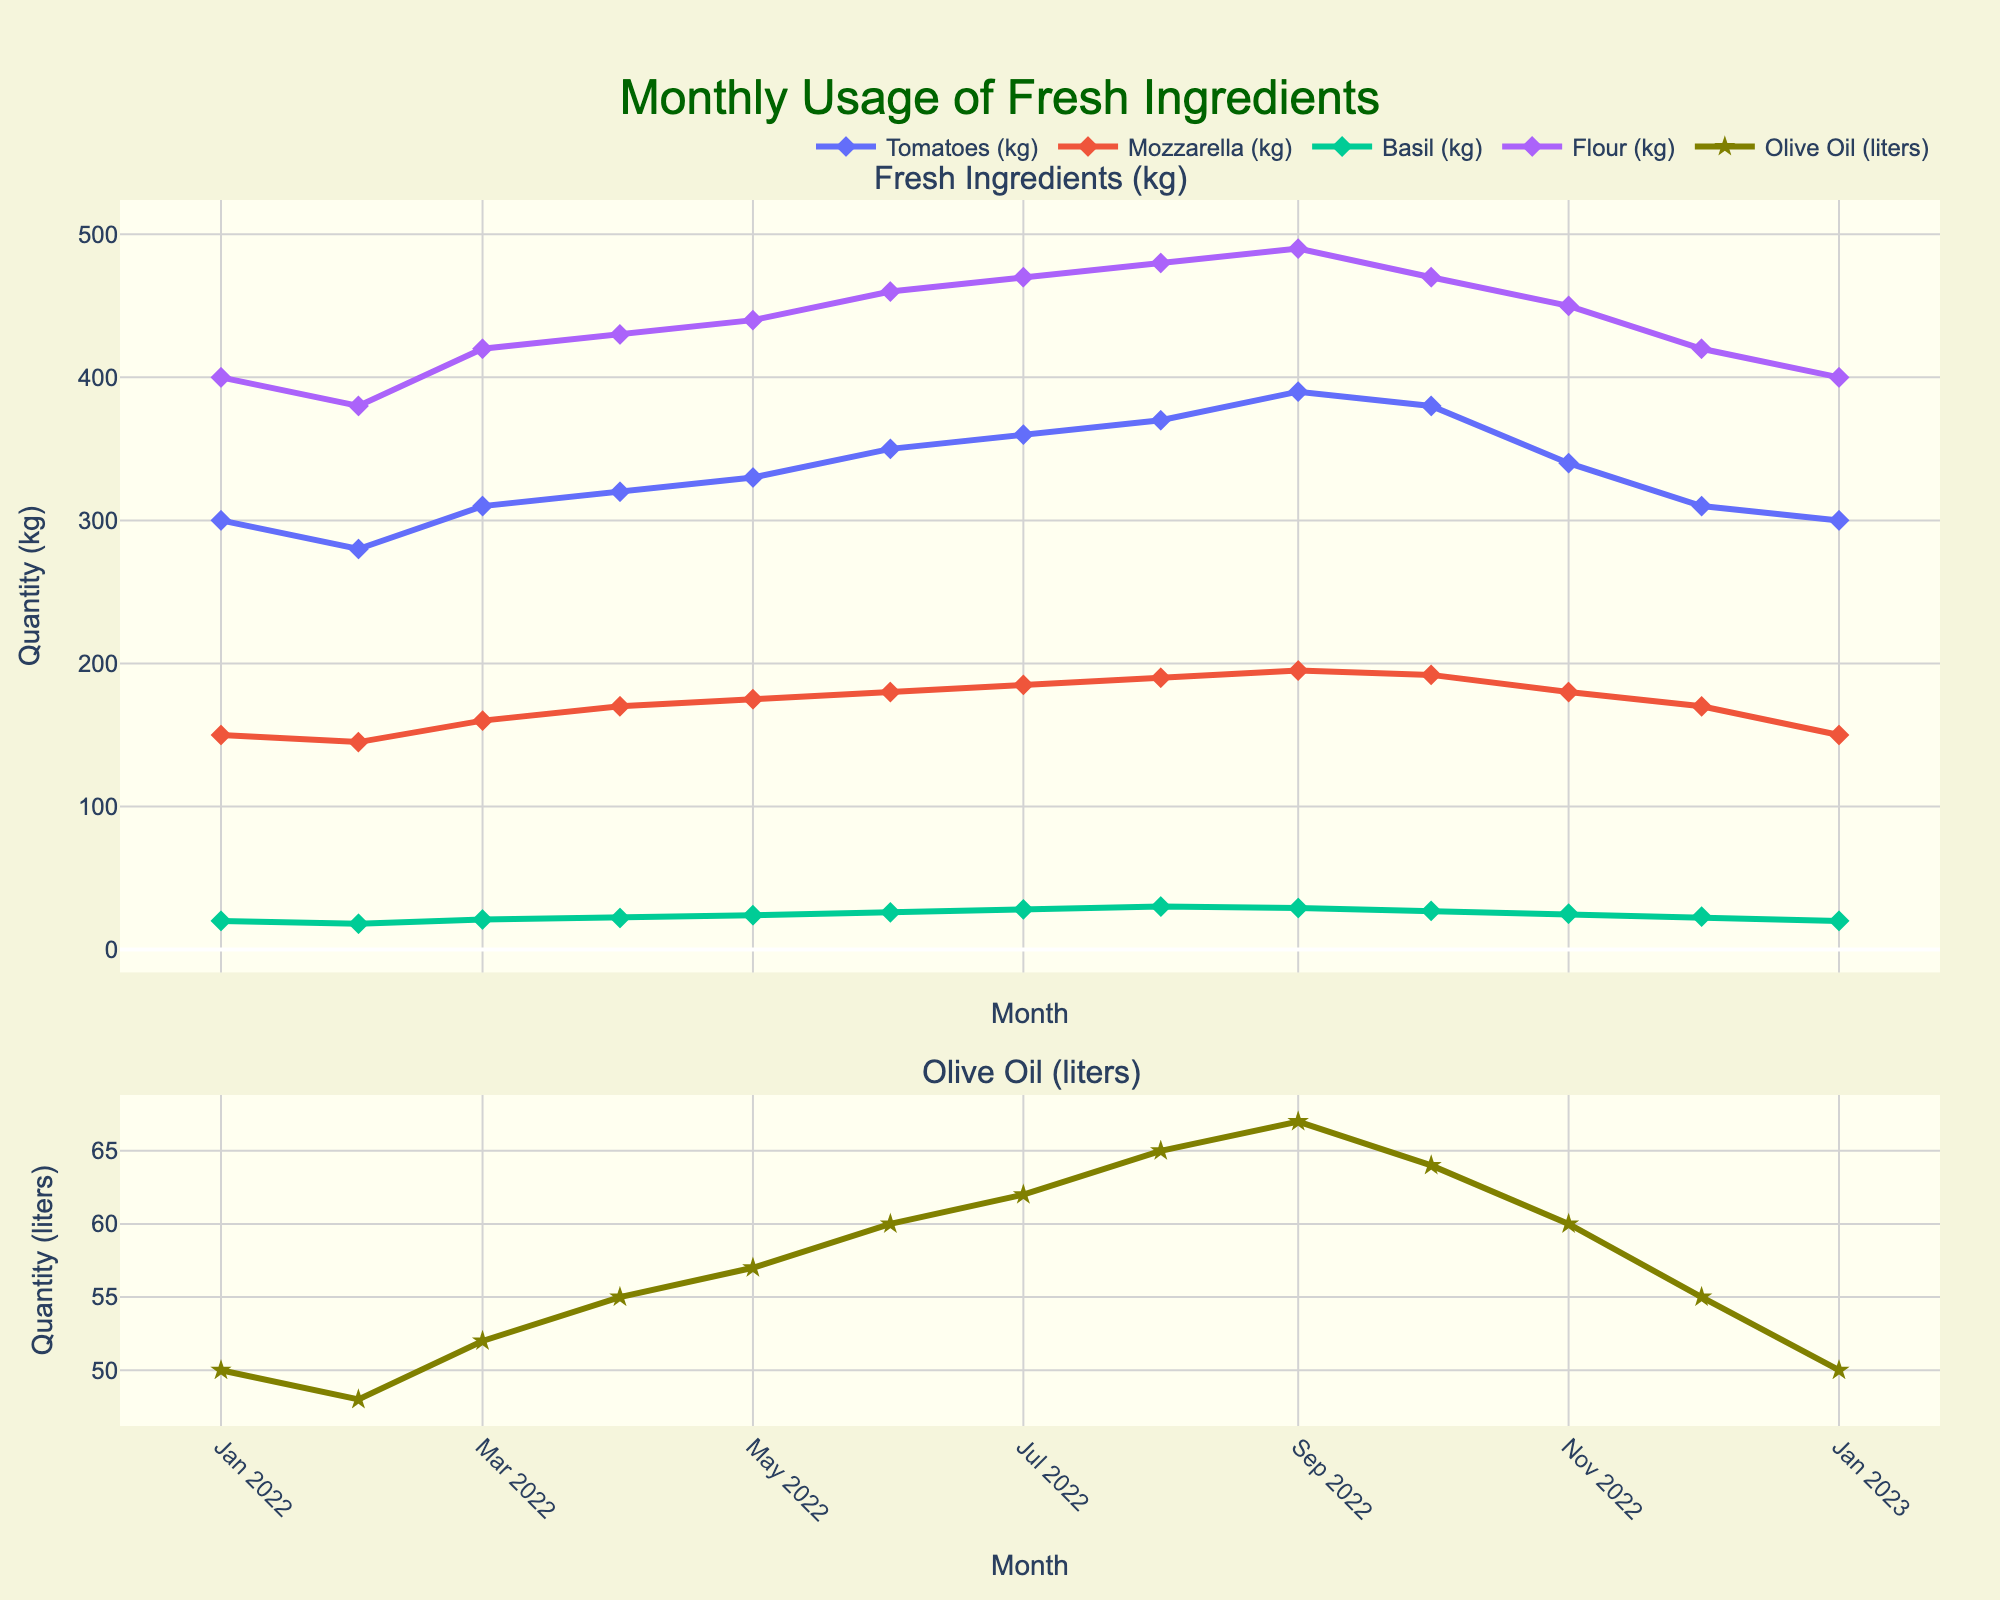What is the title of the figure? The title of the figure is located at the top and provides a summary of the data represented in the plot. It is "Monthly Usage of Fresh Ingredients."
Answer: Monthly Usage of Fresh Ingredients How many subplots are there in the figure? By observing the layout, we can see two distinct subplots stacked vertically.
Answer: 2 Which ingredient shows the highest quantity in July 2022? Looking at the data points for July 2022, the ingredient "Tomatoes (kg)" shows the highest quantity.
Answer: Tomatoes Between which two months does Olive Oil (liters) show the greatest increase? By visually comparing the segments of the Olive Oil line, the greatest increase appears between August 2022 and September 2022.
Answer: August to September 2022 Which month had the lowest usage of Basil (kg)? Observing the Basil line across all months, the lowest point is in January 2022.
Answer: January 2022 What is the total quantity of Flour (kg) used in the first six months? Sum the quantities for Flour (kg) from January to June 2022: 400 + 380 + 420 + 430 + 440 + 460 = 2530
Answer: 2530 Did any ingredient have the same usage in any two consecutive months? Checking across all ingredients and months, "Mozzarella (kg)" had the same usage in January 2022 and January 2023, which is 150 kg.
Answer: Yes How does the trend of Mozzarella (kg) compare from January 2022 to December 2022? By examining the line for Mozzarella (kg), we see it generally increases from January to October, then decreases slightly towards December.
Answer: Increase then decrease Which ingredient shows the steadiest increase throughout the year? The Flour (kg) line demonstrates a relatively steady and consistent increase across the months compared to the other ingredients.
Answer: Flour What is the average monthly usage of Olive Oil (liters) for the whole year? Sum the Olive Oil usages for all months and divide by 12: (50 + 48 + 52 + 55 + 57 + 60 + 62 + 65 + 67 + 64 + 60 + 55) / 12 = 55.25
Answer: 55.25 